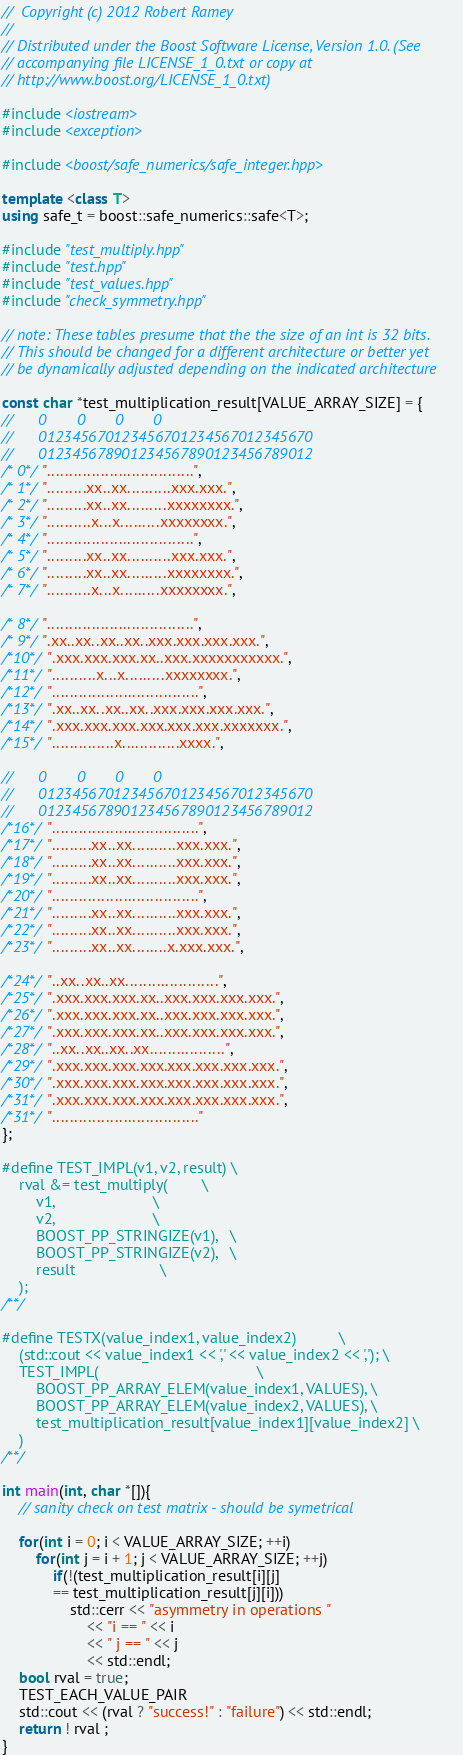Convert code to text. <code><loc_0><loc_0><loc_500><loc_500><_C++_>//  Copyright (c) 2012 Robert Ramey
//
// Distributed under the Boost Software License, Version 1.0. (See
// accompanying file LICENSE_1_0.txt or copy at
// http://www.boost.org/LICENSE_1_0.txt)

#include <iostream>
#include <exception>

#include <boost/safe_numerics/safe_integer.hpp>

template <class T>
using safe_t = boost::safe_numerics::safe<T>;

#include "test_multiply.hpp"
#include "test.hpp"
#include "test_values.hpp"
#include "check_symmetry.hpp"

// note: These tables presume that the the size of an int is 32 bits.
// This should be changed for a different architecture or better yet
// be dynamically adjusted depending on the indicated architecture

const char *test_multiplication_result[VALUE_ARRAY_SIZE] = {
//      0       0       0       0
//      012345670123456701234567012345670
//      012345678901234567890123456789012
/* 0*/ ".................................",
/* 1*/ ".........xx..xx..........xxx.xxx.",
/* 2*/ ".........xx..xx.........xxxxxxxx.",
/* 3*/ "..........x...x.........xxxxxxxx.",
/* 4*/ ".................................",
/* 5*/ ".........xx..xx..........xxx.xxx.",
/* 6*/ ".........xx..xx.........xxxxxxxx.",
/* 7*/ "..........x...x.........xxxxxxxx.",

/* 8*/ ".................................",
/* 9*/ ".xx..xx..xx..xx..xxx.xxx.xxx.xxx.",
/*10*/ ".xxx.xxx.xxx.xx..xxx.xxxxxxxxxxx.",
/*11*/ "..........x...x.........xxxxxxxx.",
/*12*/ ".................................",
/*13*/ ".xx..xx..xx..xx..xxx.xxx.xxx.xxx.",
/*14*/ ".xxx.xxx.xxx.xxx.xxx.xxx.xxxxxxx.",
/*15*/ "..............x.............xxxx.",

//      0       0       0       0
//      012345670123456701234567012345670
//      012345678901234567890123456789012
/*16*/ ".................................",
/*17*/ ".........xx..xx..........xxx.xxx.",
/*18*/ ".........xx..xx..........xxx.xxx.",
/*19*/ ".........xx..xx..........xxx.xxx.",
/*20*/ ".................................",
/*21*/ ".........xx..xx..........xxx.xxx.",
/*22*/ ".........xx..xx..........xxx.xxx.",
/*23*/ ".........xx..xx........x.xxx.xxx.",

/*24*/ "..xx..xx..xx.....................",
/*25*/ ".xxx.xxx.xxx.xx..xxx.xxx.xxx.xxx.",
/*26*/ ".xxx.xxx.xxx.xx..xxx.xxx.xxx.xxx.",
/*27*/ ".xxx.xxx.xxx.xx..xxx.xxx.xxx.xxx.",
/*28*/ "..xx..xx..xx..xx.................",
/*29*/ ".xxx.xxx.xxx.xxx.xxx.xxx.xxx.xxx.",
/*30*/ ".xxx.xxx.xxx.xxx.xxx.xxx.xxx.xxx.",
/*31*/ ".xxx.xxx.xxx.xxx.xxx.xxx.xxx.xxx.",
/*31*/ "................................."
};

#define TEST_IMPL(v1, v2, result) \
    rval &= test_multiply(        \
        v1,                       \
        v2,                       \
        BOOST_PP_STRINGIZE(v1),   \
        BOOST_PP_STRINGIZE(v2),   \
        result                    \
    );
/**/

#define TESTX(value_index1, value_index2)          \
    (std::cout << value_index1 << ',' << value_index2 << ','); \
    TEST_IMPL(                                     \
        BOOST_PP_ARRAY_ELEM(value_index1, VALUES), \
        BOOST_PP_ARRAY_ELEM(value_index2, VALUES), \
        test_multiplication_result[value_index1][value_index2] \
    )
/**/

int main(int, char *[]){
    // sanity check on test matrix - should be symetrical
    
    for(int i = 0; i < VALUE_ARRAY_SIZE; ++i)
        for(int j = i + 1; j < VALUE_ARRAY_SIZE; ++j)
            if(!(test_multiplication_result[i][j]
            == test_multiplication_result[j][i]))
                std::cerr << "asymmetry in operations "
                    << "i == " << i
                    << " j == " << j
                    << std::endl;
    bool rval = true;
    TEST_EACH_VALUE_PAIR
    std::cout << (rval ? "success!" : "failure") << std::endl;
    return ! rval ;
}
</code> 